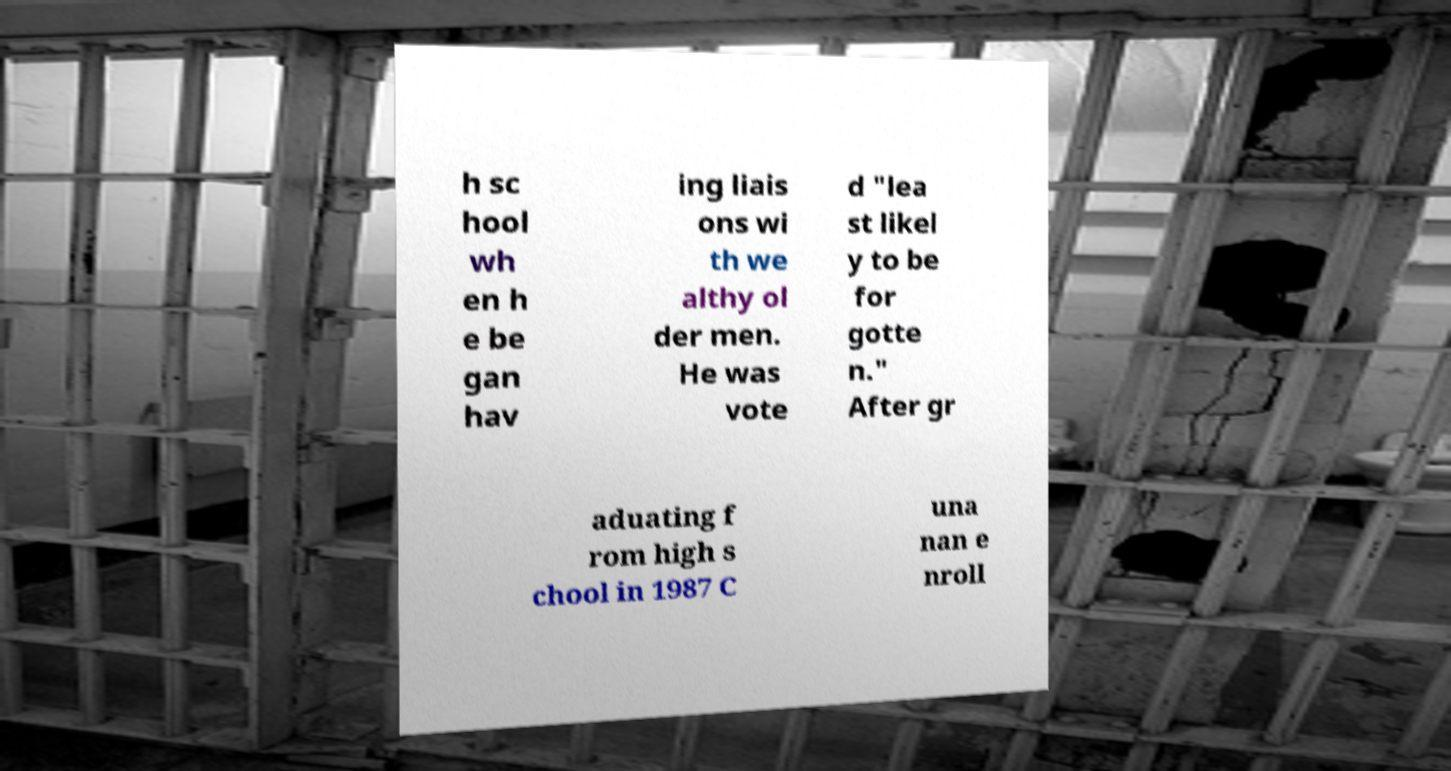I need the written content from this picture converted into text. Can you do that? h sc hool wh en h e be gan hav ing liais ons wi th we althy ol der men. He was vote d "lea st likel y to be for gotte n." After gr aduating f rom high s chool in 1987 C una nan e nroll 